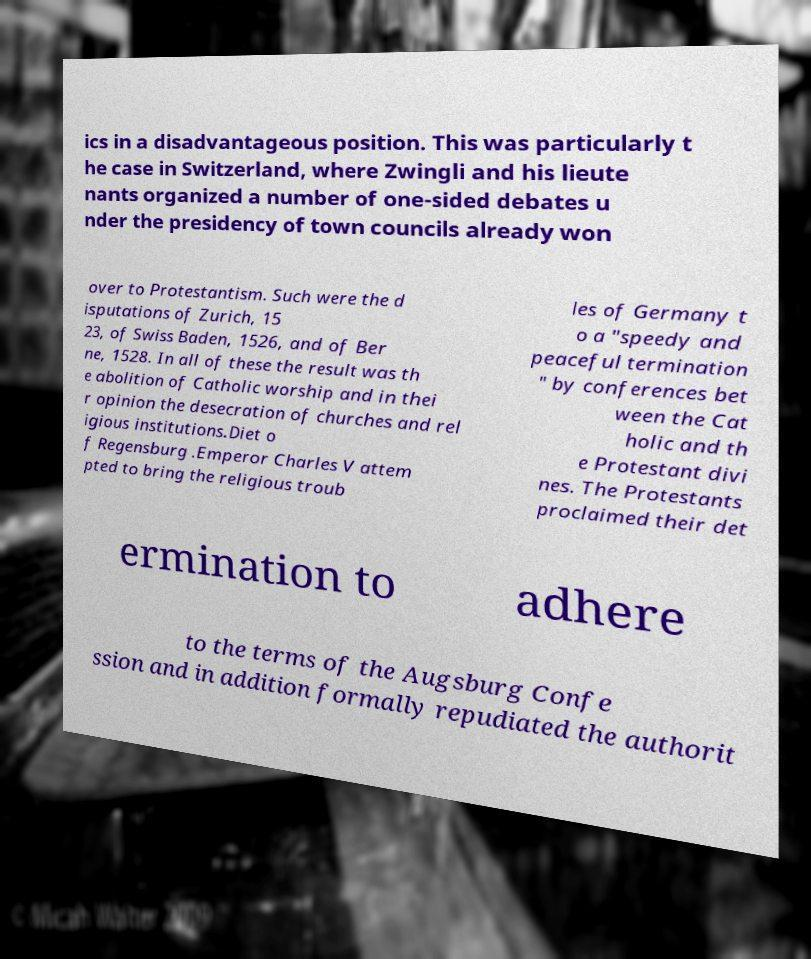Please read and relay the text visible in this image. What does it say? ics in a disadvantageous position. This was particularly t he case in Switzerland, where Zwingli and his lieute nants organized a number of one-sided debates u nder the presidency of town councils already won over to Protestantism. Such were the d isputations of Zurich, 15 23, of Swiss Baden, 1526, and of Ber ne, 1528. In all of these the result was th e abolition of Catholic worship and in thei r opinion the desecration of churches and rel igious institutions.Diet o f Regensburg .Emperor Charles V attem pted to bring the religious troub les of Germany t o a "speedy and peaceful termination " by conferences bet ween the Cat holic and th e Protestant divi nes. The Protestants proclaimed their det ermination to adhere to the terms of the Augsburg Confe ssion and in addition formally repudiated the authorit 